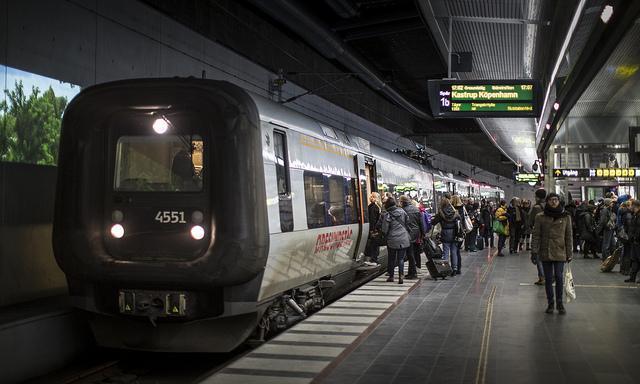How many people are visible?
Give a very brief answer. 2. 